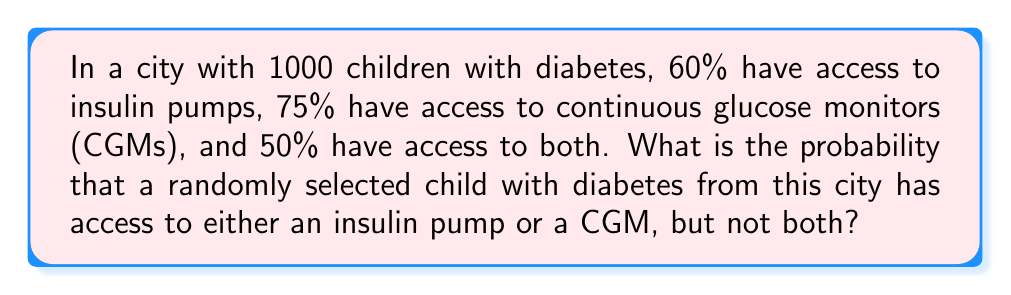What is the answer to this math problem? Let's approach this step-by-step using set theory and probability concepts:

1) Define events:
   A: Child has access to an insulin pump
   B: Child has access to a CGM

2) Given probabilities:
   $P(A) = 0.60$
   $P(B) = 0.75$
   $P(A \cap B) = 0.50$

3) We need to find $P(A \cup B) - P(A \cap B)$

4) Use the addition rule of probability:
   $P(A \cup B) = P(A) + P(B) - P(A \cap B)$

5) Substitute the values:
   $P(A \cup B) = 0.60 + 0.75 - 0.50 = 0.85$

6) Calculate the probability of having access to either but not both:
   $P(\text{either but not both}) = P(A \cup B) - P(A \cap B)$
   $= 0.85 - 0.50 = 0.35$

Therefore, the probability is 0.35 or 35%.
Answer: 0.35 